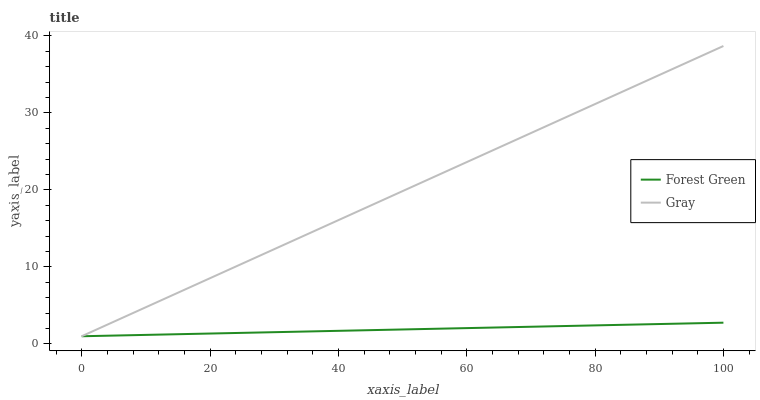Does Forest Green have the minimum area under the curve?
Answer yes or no. Yes. Does Gray have the maximum area under the curve?
Answer yes or no. Yes. Does Forest Green have the maximum area under the curve?
Answer yes or no. No. Is Forest Green the smoothest?
Answer yes or no. Yes. Is Gray the roughest?
Answer yes or no. Yes. Is Forest Green the roughest?
Answer yes or no. No. Does Gray have the lowest value?
Answer yes or no. Yes. Does Gray have the highest value?
Answer yes or no. Yes. Does Forest Green have the highest value?
Answer yes or no. No. Does Gray intersect Forest Green?
Answer yes or no. Yes. Is Gray less than Forest Green?
Answer yes or no. No. Is Gray greater than Forest Green?
Answer yes or no. No. 